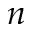Convert formula to latex. <formula><loc_0><loc_0><loc_500><loc_500>n</formula> 